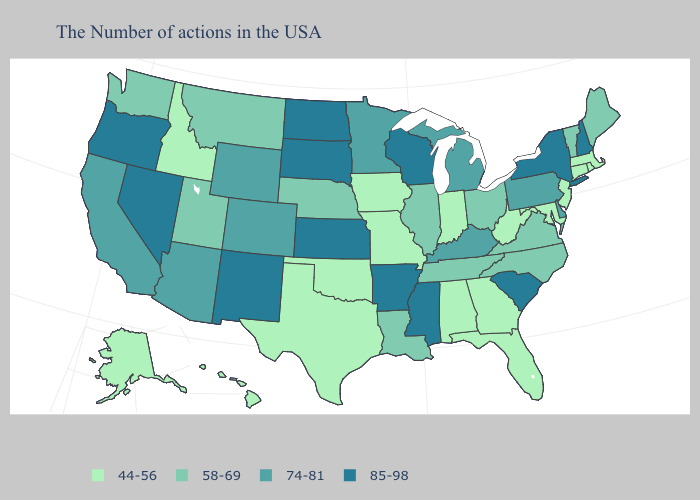What is the value of Illinois?
Give a very brief answer. 58-69. Name the states that have a value in the range 85-98?
Short answer required. New Hampshire, New York, South Carolina, Wisconsin, Mississippi, Arkansas, Kansas, South Dakota, North Dakota, New Mexico, Nevada, Oregon. Does New York have the same value as Alabama?
Be succinct. No. Among the states that border Michigan , which have the lowest value?
Quick response, please. Indiana. What is the value of Mississippi?
Keep it brief. 85-98. What is the value of West Virginia?
Concise answer only. 44-56. Does Washington have the lowest value in the USA?
Answer briefly. No. Does Kansas have the same value as New Hampshire?
Quick response, please. Yes. What is the value of Tennessee?
Keep it brief. 58-69. What is the value of Connecticut?
Keep it brief. 44-56. Name the states that have a value in the range 44-56?
Be succinct. Massachusetts, Rhode Island, Connecticut, New Jersey, Maryland, West Virginia, Florida, Georgia, Indiana, Alabama, Missouri, Iowa, Oklahoma, Texas, Idaho, Alaska, Hawaii. What is the highest value in the MidWest ?
Short answer required. 85-98. Name the states that have a value in the range 58-69?
Short answer required. Maine, Vermont, Virginia, North Carolina, Ohio, Tennessee, Illinois, Louisiana, Nebraska, Utah, Montana, Washington. Does Kansas have the highest value in the USA?
Keep it brief. Yes. Name the states that have a value in the range 58-69?
Concise answer only. Maine, Vermont, Virginia, North Carolina, Ohio, Tennessee, Illinois, Louisiana, Nebraska, Utah, Montana, Washington. 